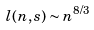Convert formula to latex. <formula><loc_0><loc_0><loc_500><loc_500>l ( n , s ) \sim n ^ { 8 / 3 }</formula> 